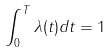<formula> <loc_0><loc_0><loc_500><loc_500>\int _ { 0 } ^ { T } \lambda ( t ) d t = 1</formula> 